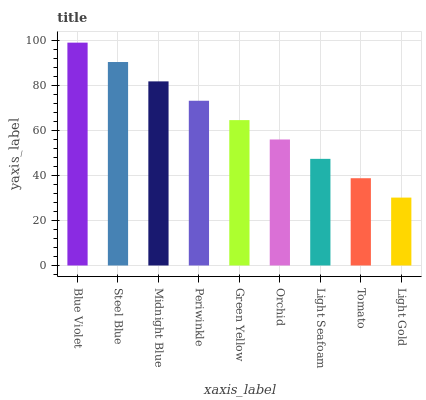Is Light Gold the minimum?
Answer yes or no. Yes. Is Blue Violet the maximum?
Answer yes or no. Yes. Is Steel Blue the minimum?
Answer yes or no. No. Is Steel Blue the maximum?
Answer yes or no. No. Is Blue Violet greater than Steel Blue?
Answer yes or no. Yes. Is Steel Blue less than Blue Violet?
Answer yes or no. Yes. Is Steel Blue greater than Blue Violet?
Answer yes or no. No. Is Blue Violet less than Steel Blue?
Answer yes or no. No. Is Green Yellow the high median?
Answer yes or no. Yes. Is Green Yellow the low median?
Answer yes or no. Yes. Is Tomato the high median?
Answer yes or no. No. Is Steel Blue the low median?
Answer yes or no. No. 